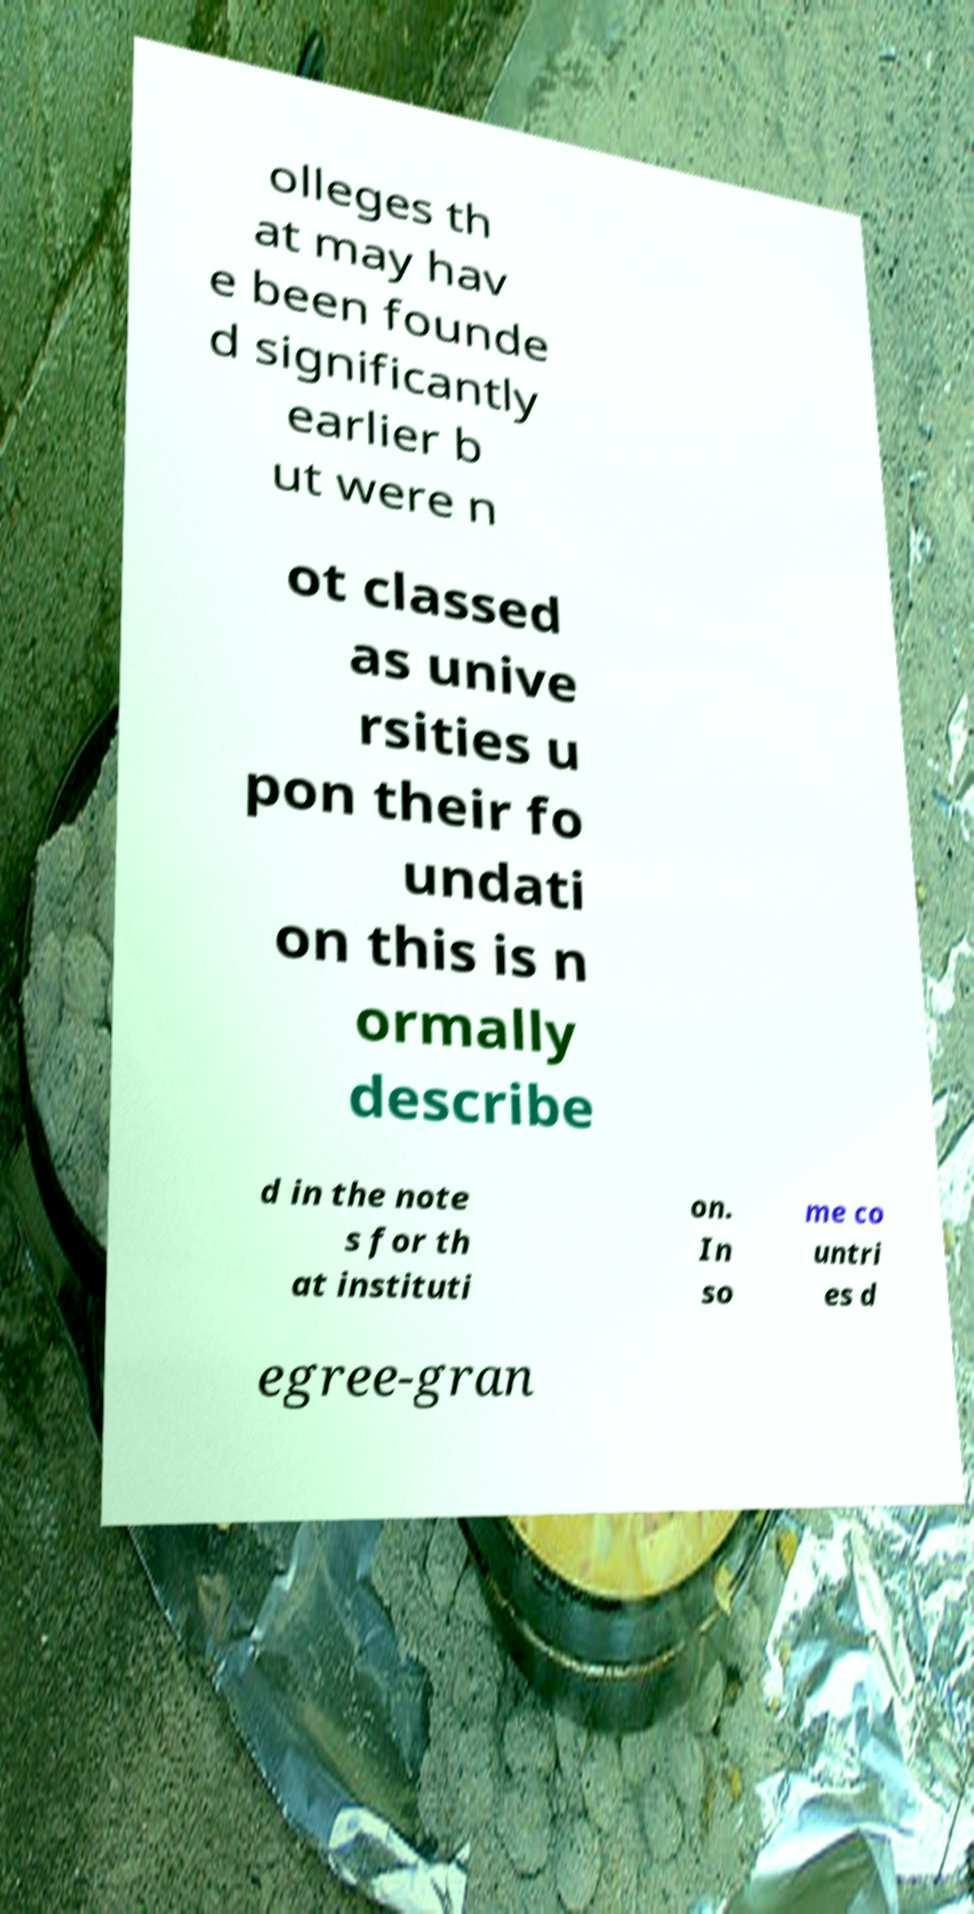Please read and relay the text visible in this image. What does it say? olleges th at may hav e been founde d significantly earlier b ut were n ot classed as unive rsities u pon their fo undati on this is n ormally describe d in the note s for th at instituti on. In so me co untri es d egree-gran 